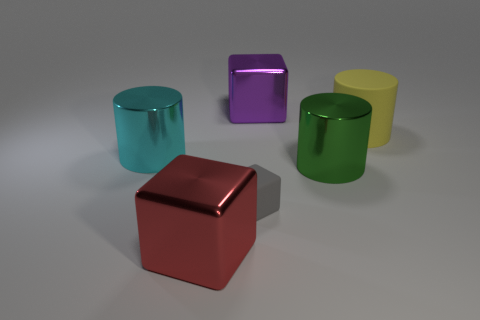Subtract all small cubes. How many cubes are left? 2 Subtract all red cubes. How many cubes are left? 2 Add 3 brown cylinders. How many objects exist? 9 Subtract 1 cubes. How many cubes are left? 2 Subtract all purple cubes. Subtract all brown balls. How many cubes are left? 2 Subtract all red rubber blocks. Subtract all green cylinders. How many objects are left? 5 Add 1 large red objects. How many large red objects are left? 2 Add 4 big objects. How many big objects exist? 9 Subtract 1 green cylinders. How many objects are left? 5 